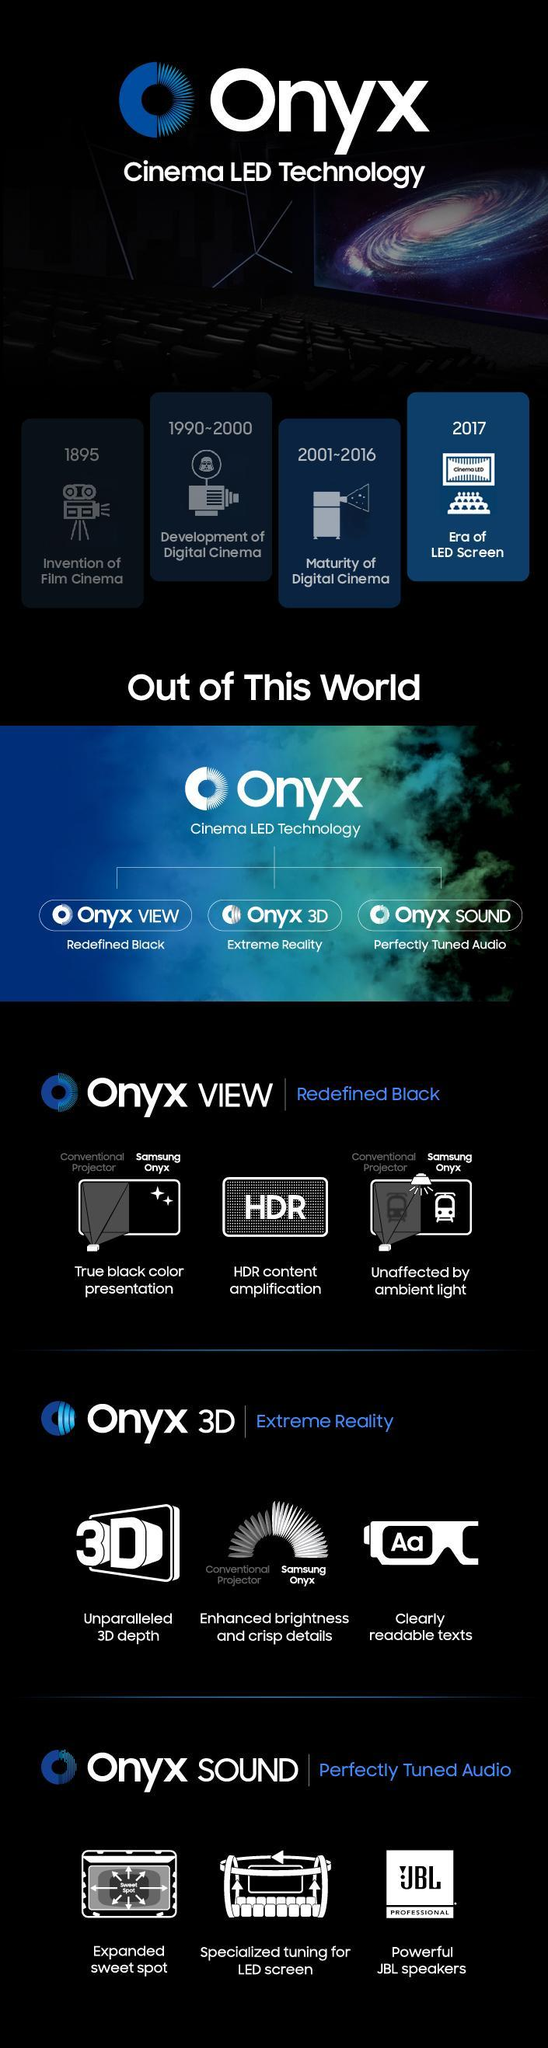When was film cinema invented?
Answer the question with a short phrase. 1895 In which year LED screens came in to effect in Cinemas? 2017 